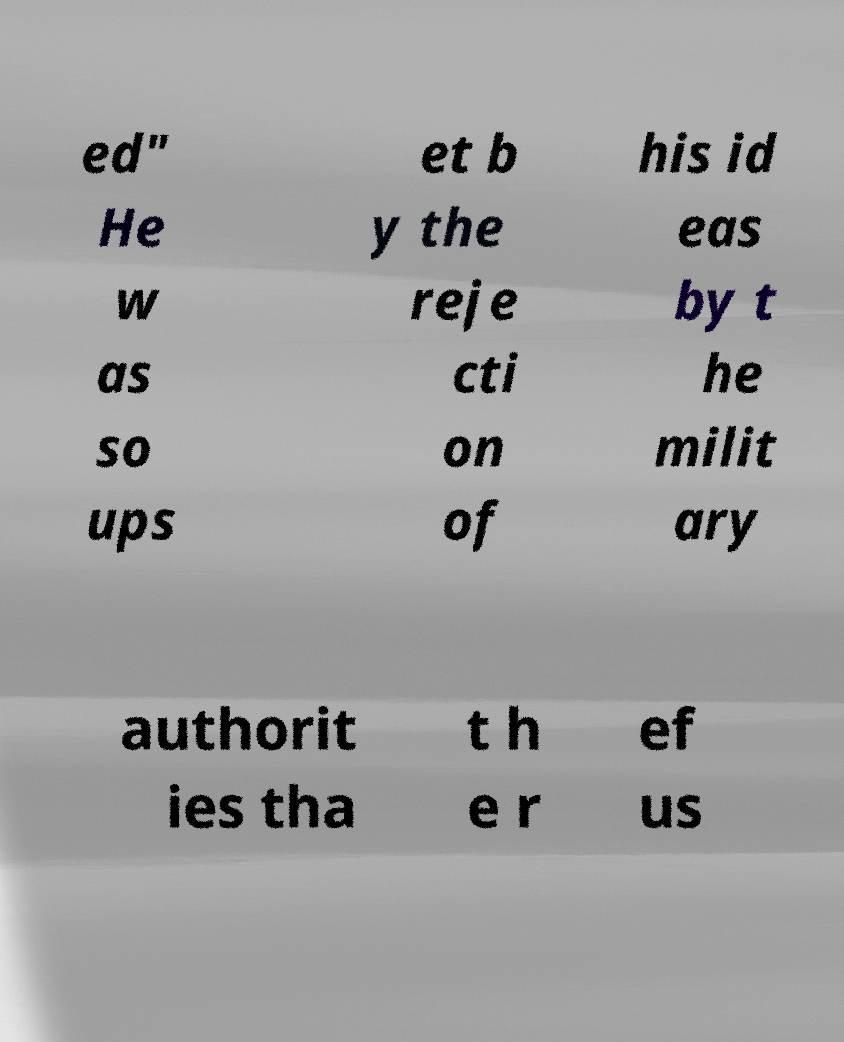There's text embedded in this image that I need extracted. Can you transcribe it verbatim? ed" He w as so ups et b y the reje cti on of his id eas by t he milit ary authorit ies tha t h e r ef us 